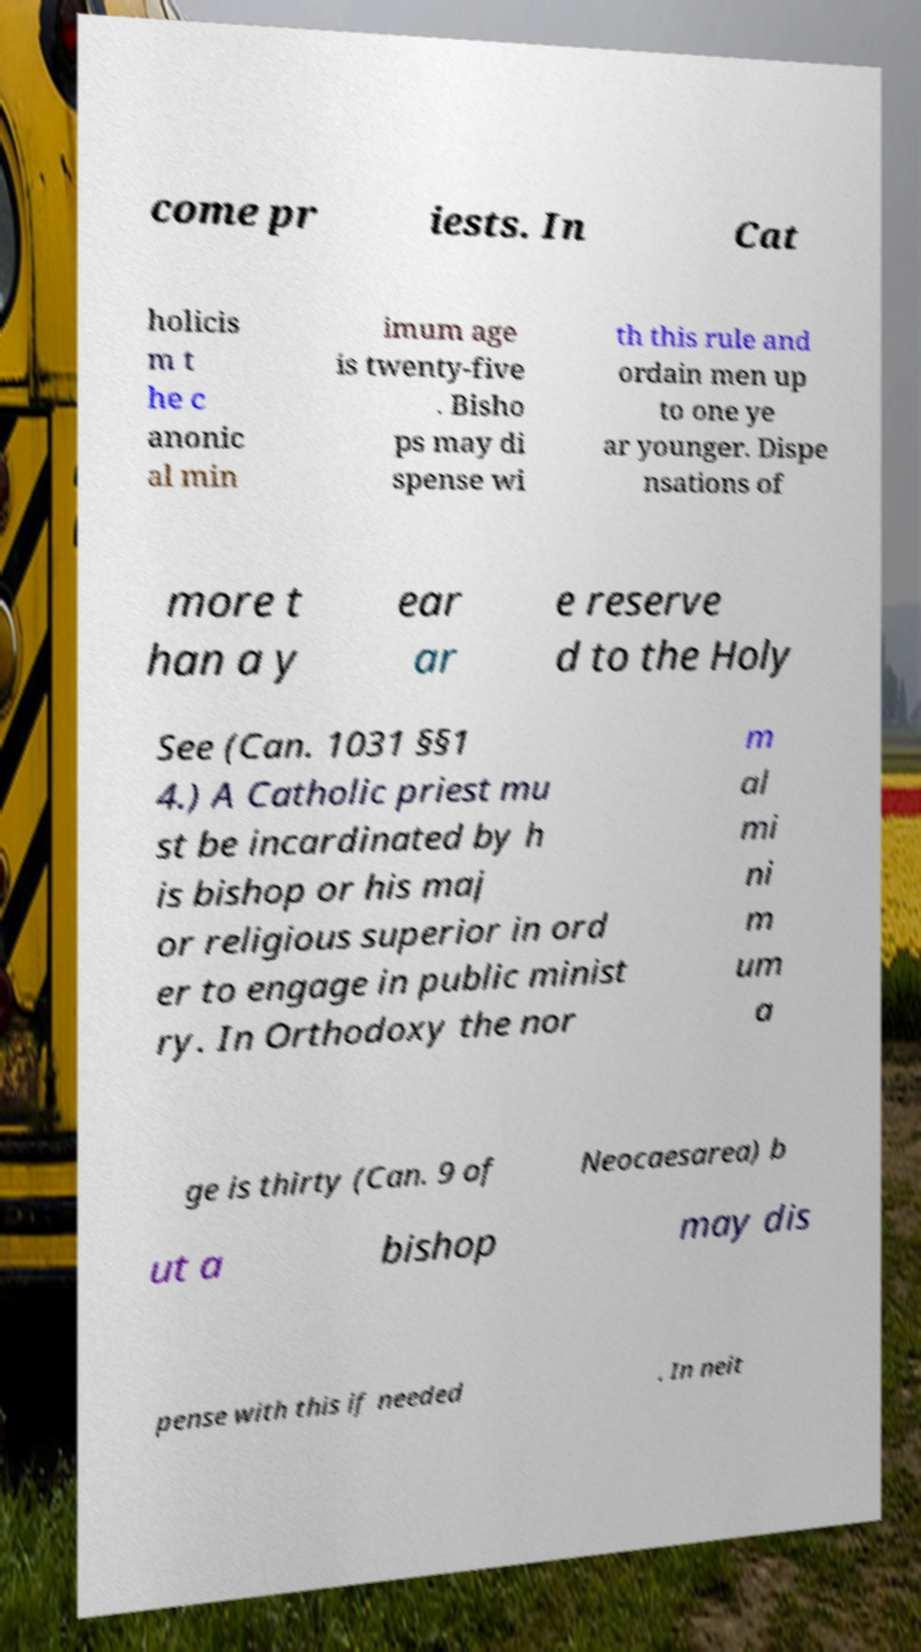Can you accurately transcribe the text from the provided image for me? come pr iests. In Cat holicis m t he c anonic al min imum age is twenty-five . Bisho ps may di spense wi th this rule and ordain men up to one ye ar younger. Dispe nsations of more t han a y ear ar e reserve d to the Holy See (Can. 1031 §§1 4.) A Catholic priest mu st be incardinated by h is bishop or his maj or religious superior in ord er to engage in public minist ry. In Orthodoxy the nor m al mi ni m um a ge is thirty (Can. 9 of Neocaesarea) b ut a bishop may dis pense with this if needed . In neit 